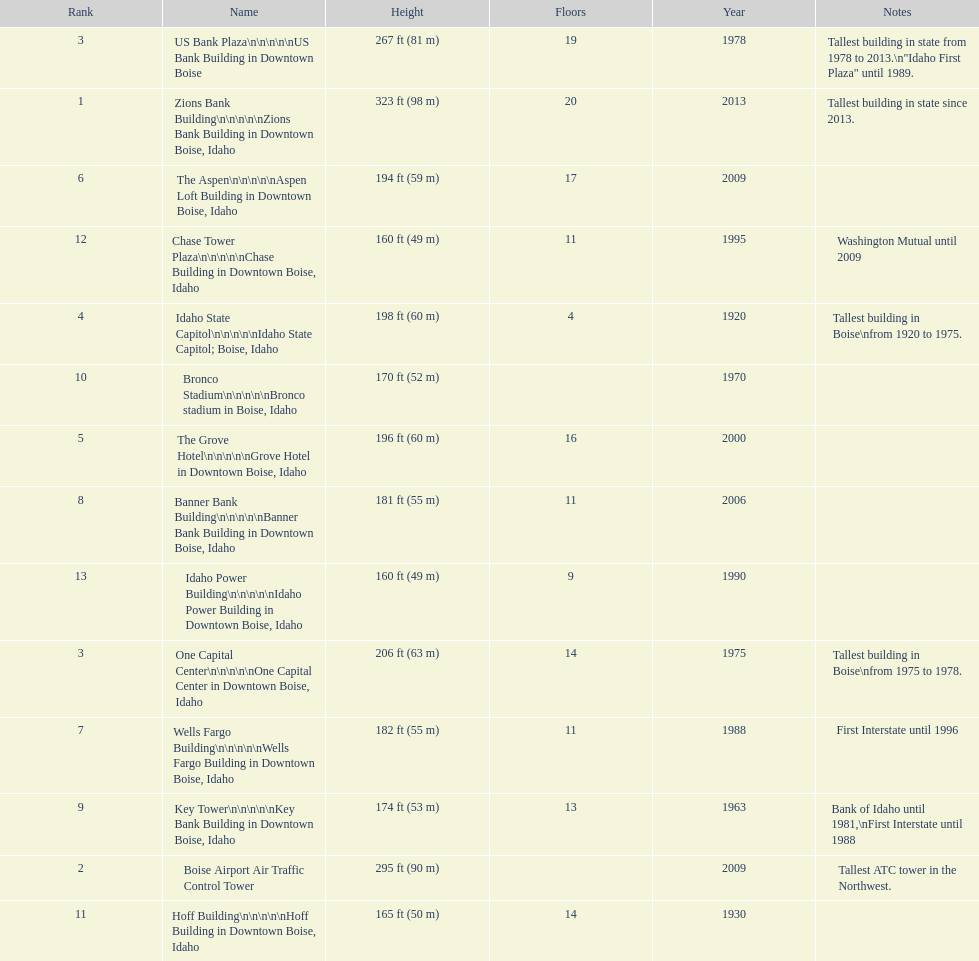What is the name of the building listed after idaho state capitol? The Grove Hotel. Parse the table in full. {'header': ['Rank', 'Name', 'Height', 'Floors', 'Year', 'Notes'], 'rows': [['3', 'US Bank Plaza\\n\\n\\n\\n\\nUS Bank Building in Downtown Boise', '267\xa0ft (81\xa0m)', '19', '1978', 'Tallest building in state from 1978 to 2013.\\n"Idaho First Plaza" until 1989.'], ['1', 'Zions Bank Building\\n\\n\\n\\n\\nZions Bank Building in Downtown Boise, Idaho', '323\xa0ft (98\xa0m)', '20', '2013', 'Tallest building in state since 2013.'], ['6', 'The Aspen\\n\\n\\n\\n\\nAspen Loft Building in Downtown Boise, Idaho', '194\xa0ft (59\xa0m)', '17', '2009', ''], ['12', 'Chase Tower Plaza\\n\\n\\n\\n\\nChase Building in Downtown Boise, Idaho', '160\xa0ft (49\xa0m)', '11', '1995', 'Washington Mutual until 2009'], ['4', 'Idaho State Capitol\\n\\n\\n\\n\\nIdaho State Capitol; Boise, Idaho', '198\xa0ft (60\xa0m)', '4', '1920', 'Tallest building in Boise\\nfrom 1920 to 1975.'], ['10', 'Bronco Stadium\\n\\n\\n\\n\\nBronco stadium in Boise, Idaho', '170\xa0ft (52\xa0m)', '', '1970', ''], ['5', 'The Grove Hotel\\n\\n\\n\\n\\nGrove Hotel in Downtown Boise, Idaho', '196\xa0ft (60\xa0m)', '16', '2000', ''], ['8', 'Banner Bank Building\\n\\n\\n\\n\\nBanner Bank Building in Downtown Boise, Idaho', '181\xa0ft (55\xa0m)', '11', '2006', ''], ['13', 'Idaho Power Building\\n\\n\\n\\n\\nIdaho Power Building in Downtown Boise, Idaho', '160\xa0ft (49\xa0m)', '9', '1990', ''], ['3', 'One Capital Center\\n\\n\\n\\n\\nOne Capital Center in Downtown Boise, Idaho', '206\xa0ft (63\xa0m)', '14', '1975', 'Tallest building in Boise\\nfrom 1975 to 1978.'], ['7', 'Wells Fargo Building\\n\\n\\n\\n\\nWells Fargo Building in Downtown Boise, Idaho', '182\xa0ft (55\xa0m)', '11', '1988', 'First Interstate until 1996'], ['9', 'Key Tower\\n\\n\\n\\n\\nKey Bank Building in Downtown Boise, Idaho', '174\xa0ft (53\xa0m)', '13', '1963', 'Bank of Idaho until 1981,\\nFirst Interstate until 1988'], ['2', 'Boise Airport Air Traffic Control Tower', '295\xa0ft (90\xa0m)', '', '2009', 'Tallest ATC tower in the Northwest.'], ['11', 'Hoff Building\\n\\n\\n\\n\\nHoff Building in Downtown Boise, Idaho', '165\xa0ft (50\xa0m)', '14', '1930', '']]} 